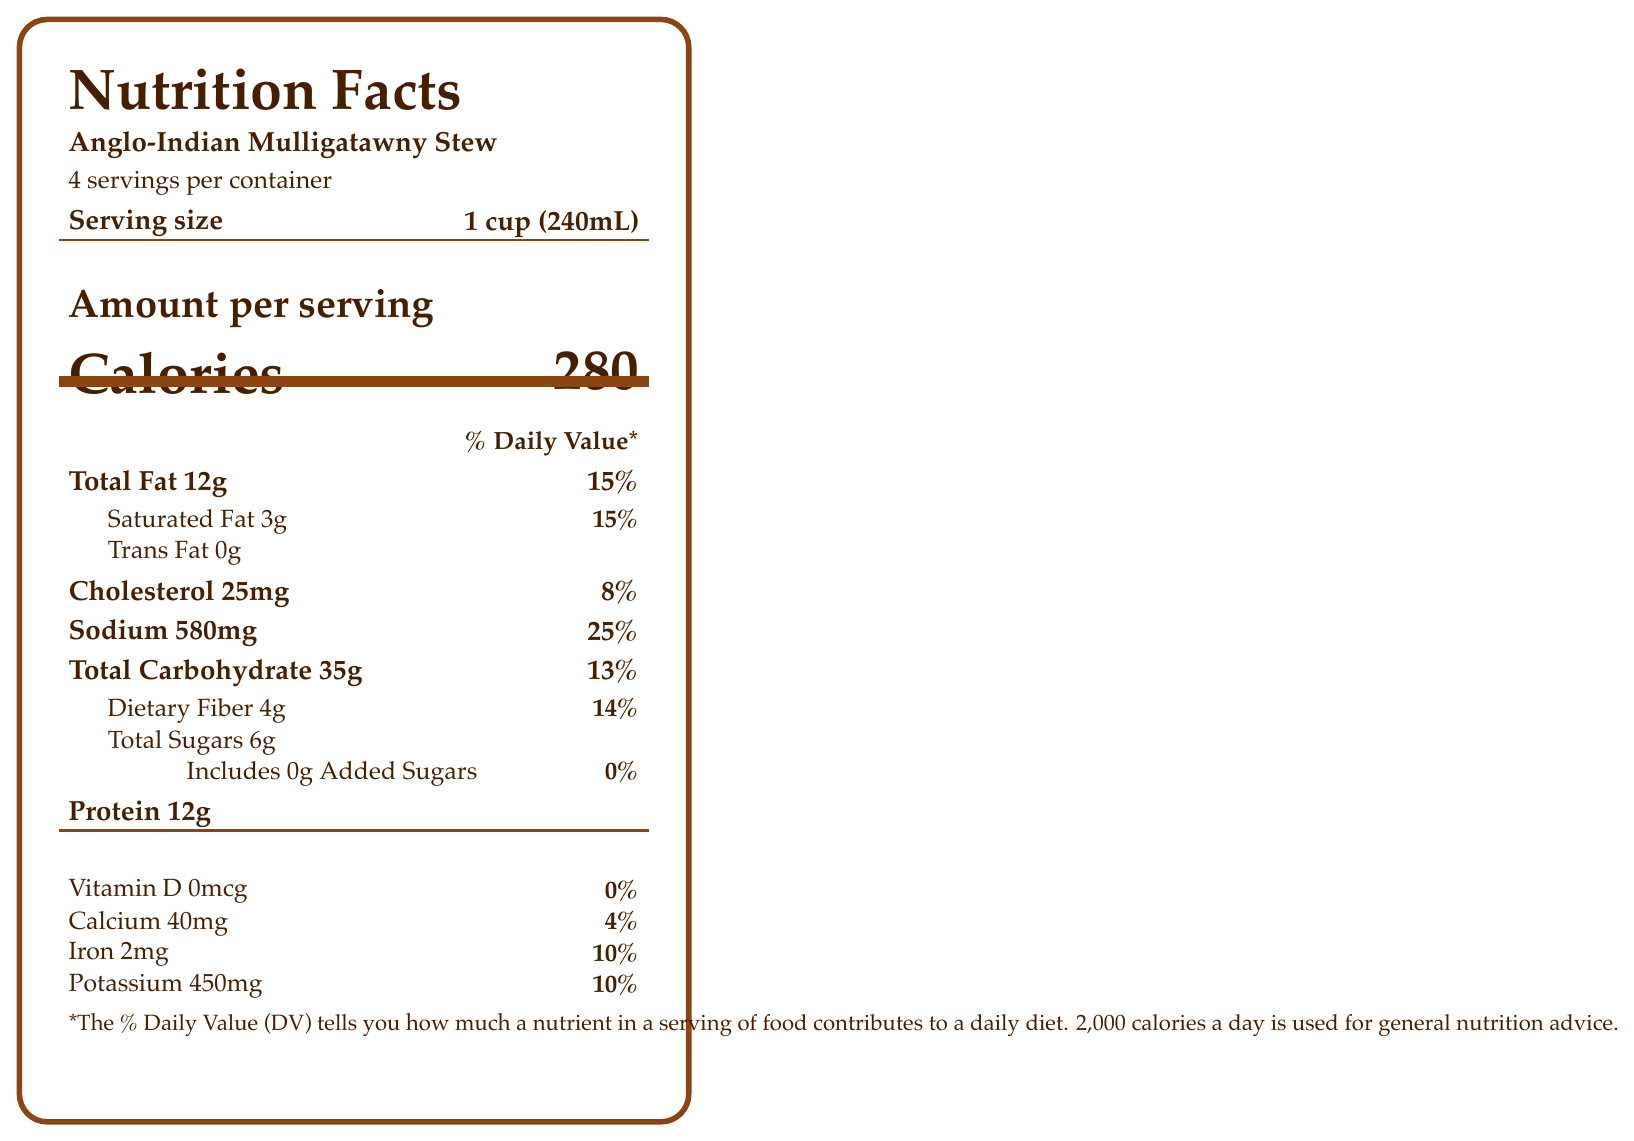what is the serving size of the Anglo-Indian Mulligatawny Stew? The serving size is specified as “1 cup (240mL)” in the document.
Answer: 1 cup (240mL) how many calories are in one serving of the stew? The document states that one serving of the stew contains 280 calories.
Answer: 280 what percentage of the daily value for sodium does one serving of the stew provide? The sodium content per serving is 580mg, which is 25% of the daily value.
Answer: 25% how much dietary fiber is in one serving? The document indicates that each serving contains 4 grams of dietary fiber.
Answer: 4g what is the total fat content in one serving? The nutritional information shows that there are 12 grams of total fat per serving.
Answer: 12g what ingredient is NOT listed in the stew? A. Bay leaves B. Basmati rice C. Potatoes D. Coconut milk The ingredient list includes bay leaves, basmati rice, and coconut milk, but not potatoes.
Answer: C. Potatoes which vitamins and minerals are included in the document? A. Vitamin A, Vitamin D, Iron B. Vitamin D, Calcium, Potassium C. Vitamin C, Iron, Calcium The document lists vitamin D, calcium, iron, and potassium, but not vitamin A or C.
Answer: B. Vitamin D, Calcium, Potassium is there any trans fat in the stew? The document specifies that there are 0 grams of trans fat.
Answer: No describe the main information presented in the document. This document outlines the nutritional breakdown of the stew, listing macronutrient and micronutrient information, serving size, and historical and cultural context.
Answer: The document provides the nutritional facts for Anglo-Indian Mulligatawny Stew, highlighting the blend of Indian and British culinary traditions. It includes serving size, calories, macronutrients, and percentages of daily values for various nutrients as well as an ingredient list. The historical significance and cultural impacts of the dish are also discussed. how much cholesterol is in one serving of the stew? The cholesterol content in one serving is specified as 25mg.
Answer: 25mg how many grams of added sugars are in the stew? The document indicates that there are 0 grams of added sugars in the stew.
Answer: 0g can you determine the exact historical sources or recipes for the stew from the visual document alone? The document does not provide specific details on the historical sources or recipes beyond mentioning that it was adapted from 'The Indian Cookery Book' by Anonymous, published in Calcutta, 1880.
Answer: Cannot be determined 